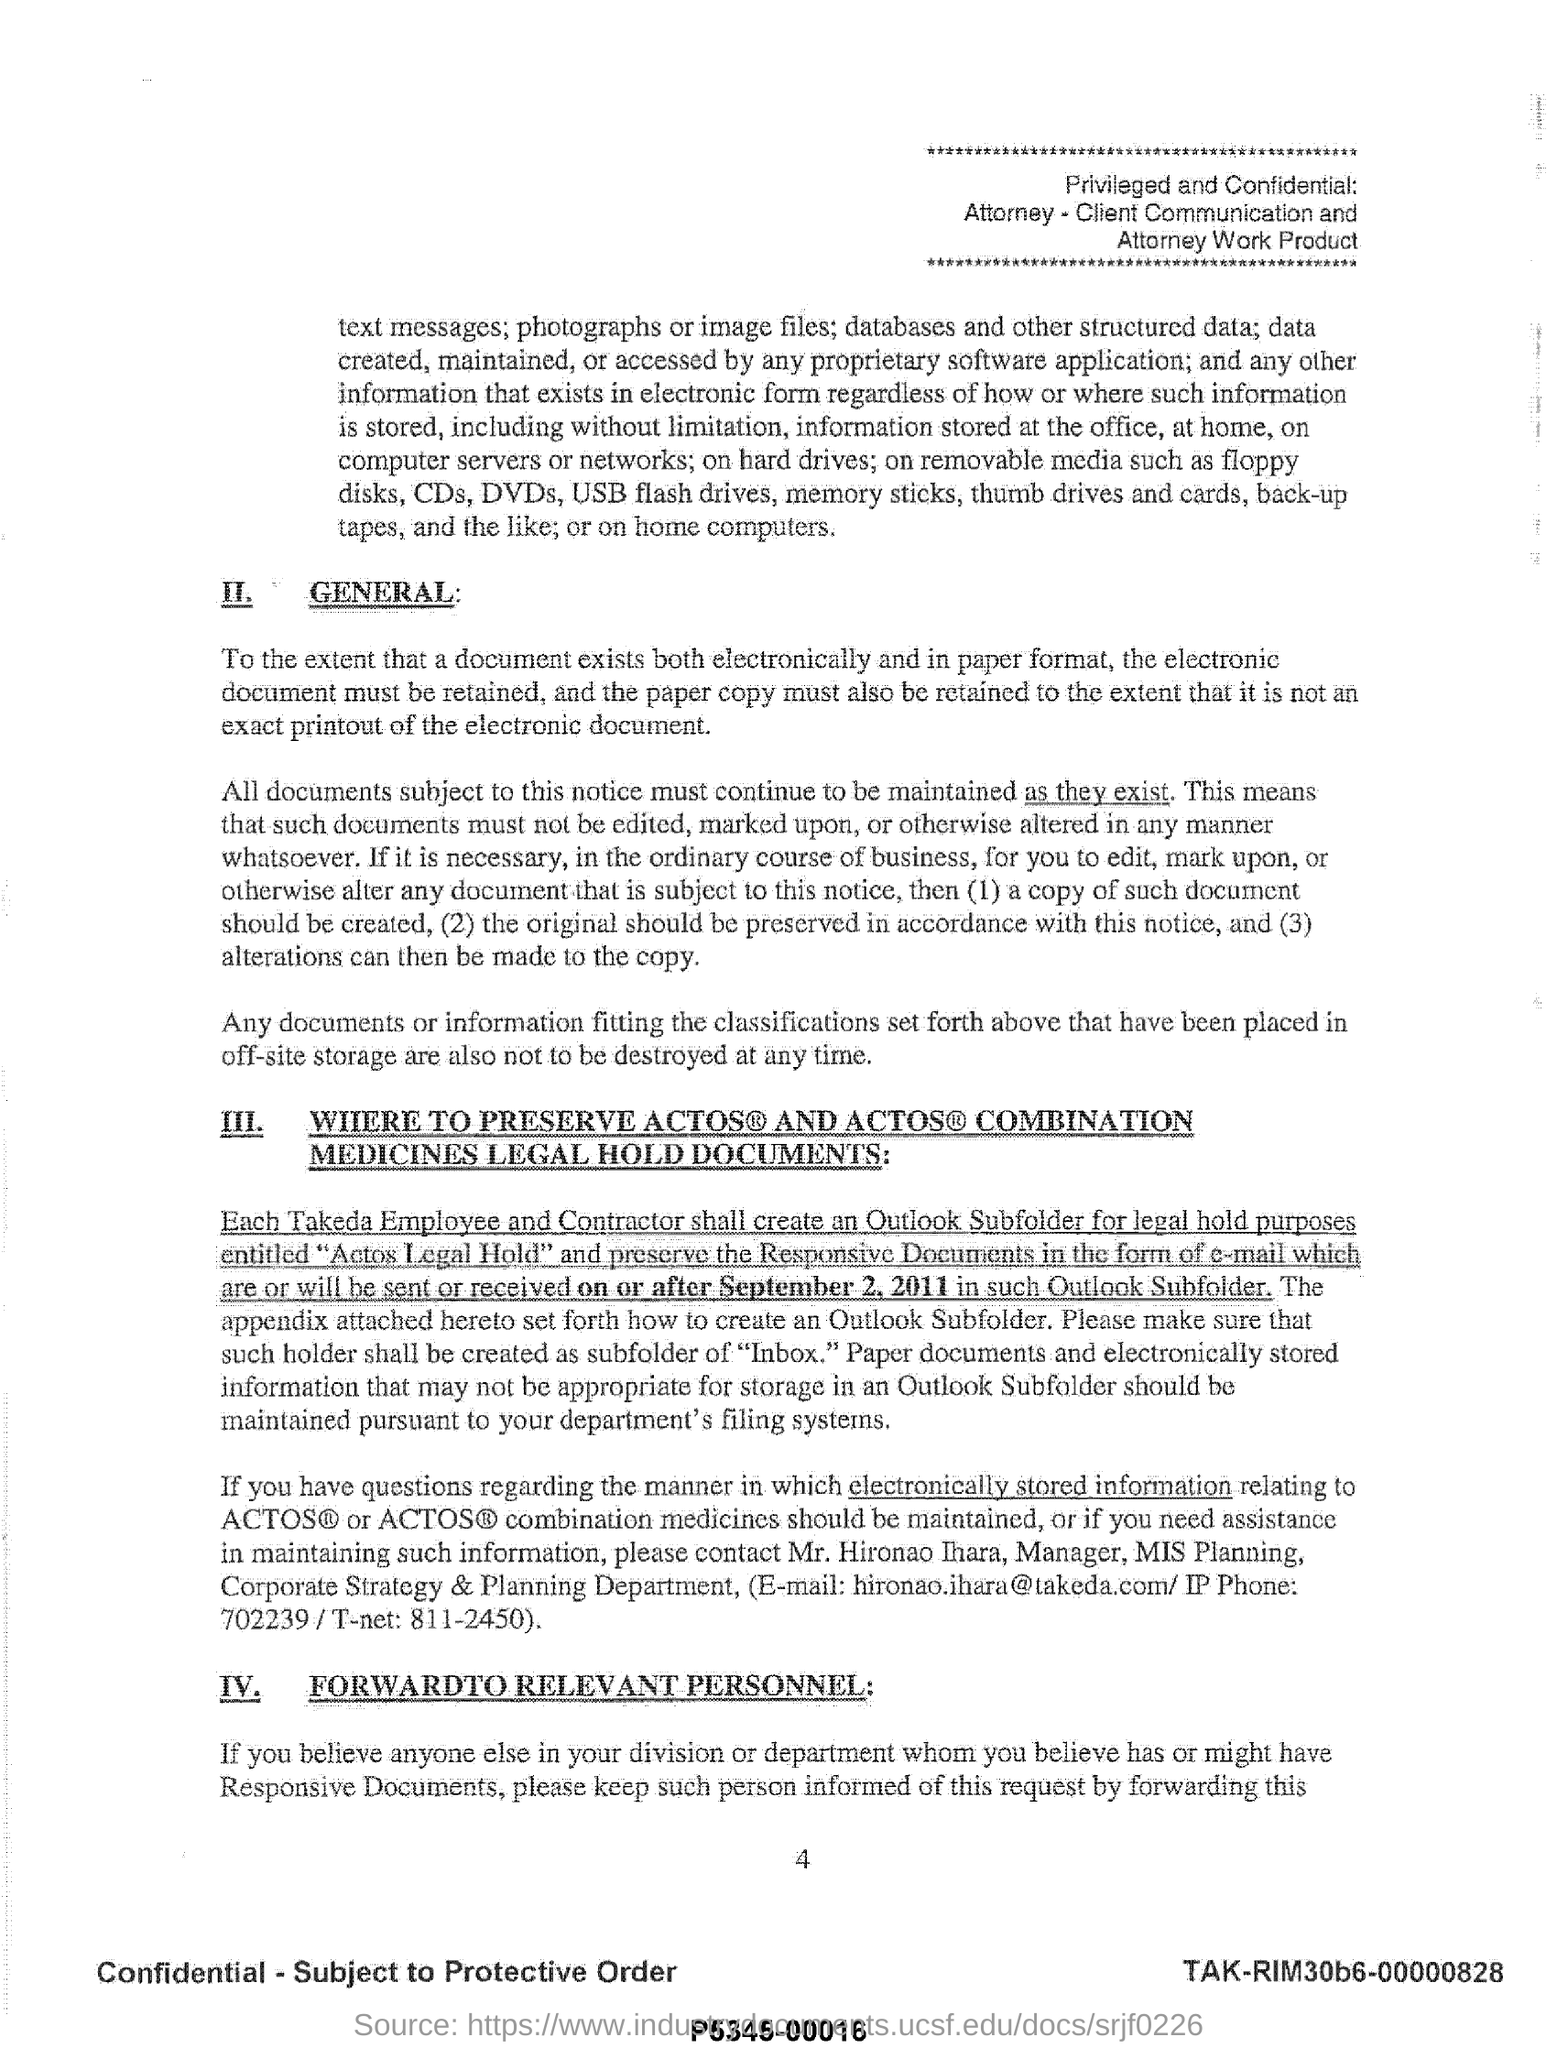Give some essential details in this illustration. The manager of MIS planning is Mr. Hironao Ihara. I have a phone number for Mr. Hironao Ihara. It is 702239... Mr. Hironao Ihara can be contacted via his email address [hironao.ihara@takeda.com](mailto:hironao.ihara@takeda.com). 